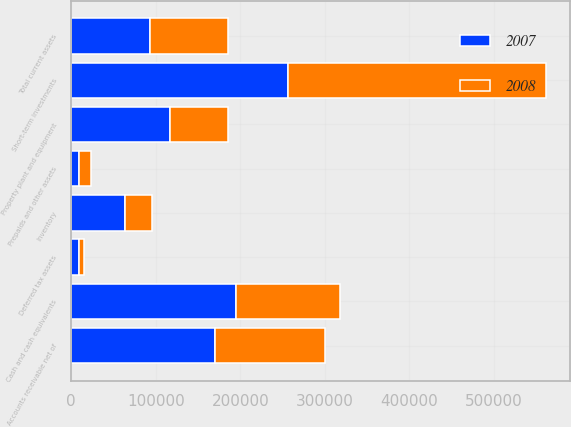<chart> <loc_0><loc_0><loc_500><loc_500><stacked_bar_chart><ecel><fcel>Cash and cash equivalents<fcel>Short-term investments<fcel>Accounts receivable net of<fcel>Inventory<fcel>Prepaids and other assets<fcel>Deferred tax assets<fcel>Total current assets<fcel>Property plant and equipment<nl><fcel>2007<fcel>194623<fcel>256746<fcel>170107<fcel>63460<fcel>9496<fcel>9458<fcel>92557<fcel>117021<nl><fcel>2008<fcel>122825<fcel>304642<fcel>130370<fcel>32416<fcel>13486<fcel>5852<fcel>92557<fcel>68093<nl></chart> 